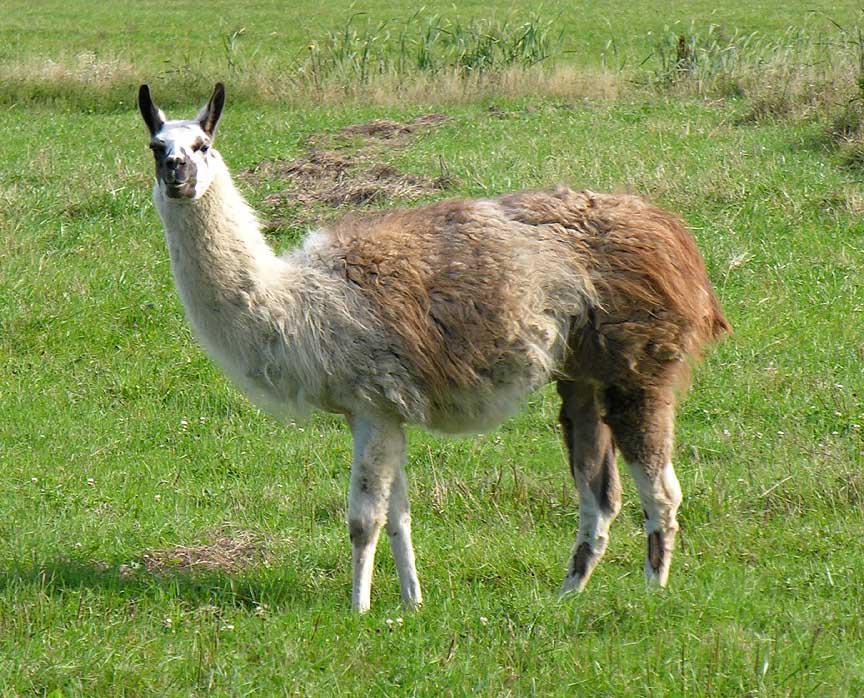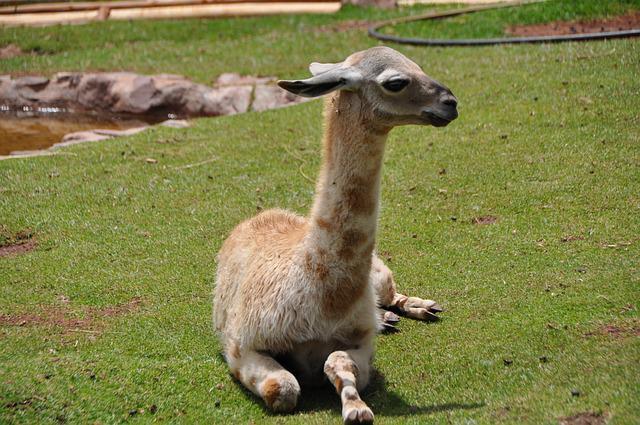The first image is the image on the left, the second image is the image on the right. Given the left and right images, does the statement "The left and right image contains the same number of llamas." hold true? Answer yes or no. Yes. The first image is the image on the left, the second image is the image on the right. Assess this claim about the two images: "There are exactly two llamas in total.". Correct or not? Answer yes or no. Yes. 